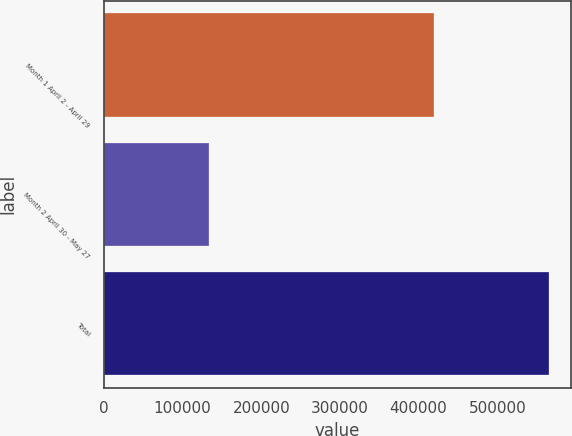Convert chart to OTSL. <chart><loc_0><loc_0><loc_500><loc_500><bar_chart><fcel>Month 1 April 2 - April 29<fcel>Month 2 April 30 - May 27<fcel>Total<nl><fcel>420141<fcel>133354<fcel>565626<nl></chart> 